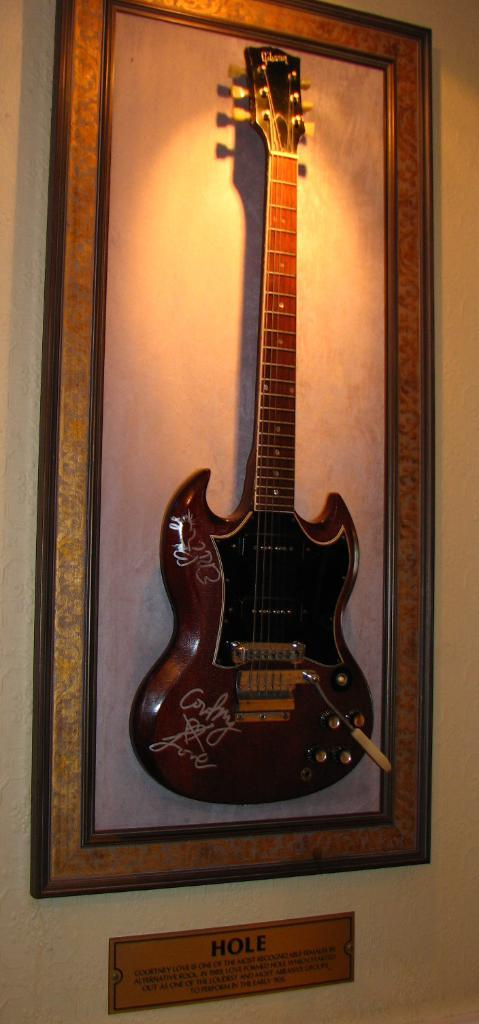<image>
Render a clear and concise summary of the photo. A gibson branded Guitar is framed on a wal with a sign that reads Hole beneath the frame. 